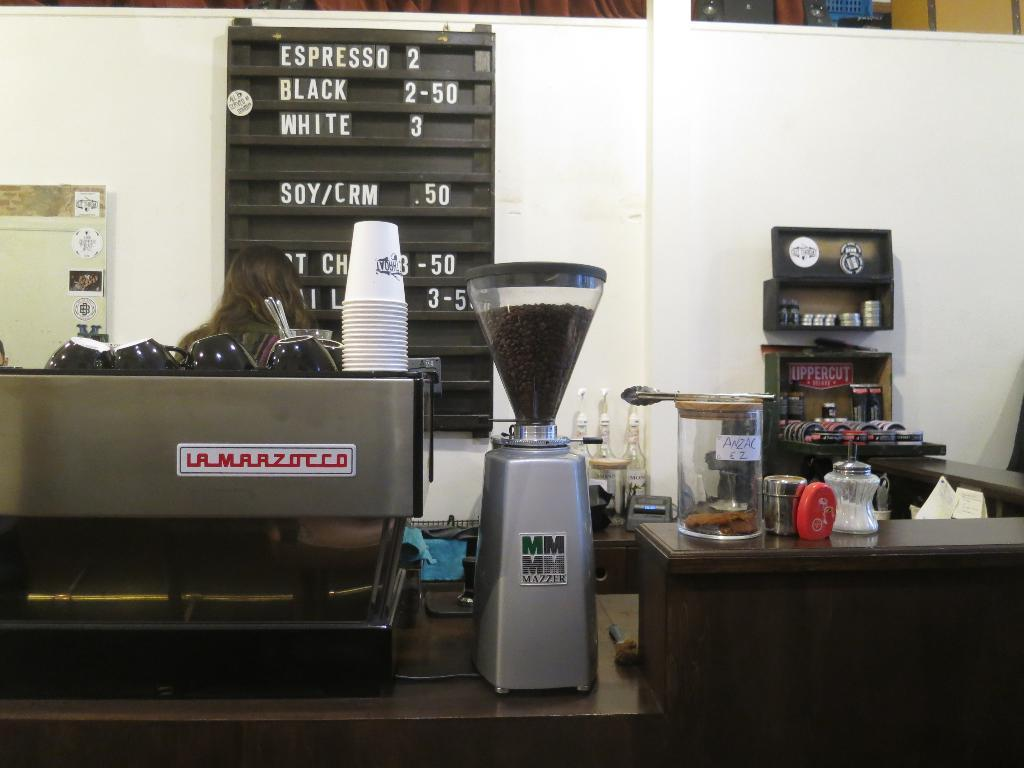<image>
Offer a succinct explanation of the picture presented. A small coffee station set up with a coffee grinder and a black board in the back that has such things as Espresso 2, Black 2-50, and white 3. 